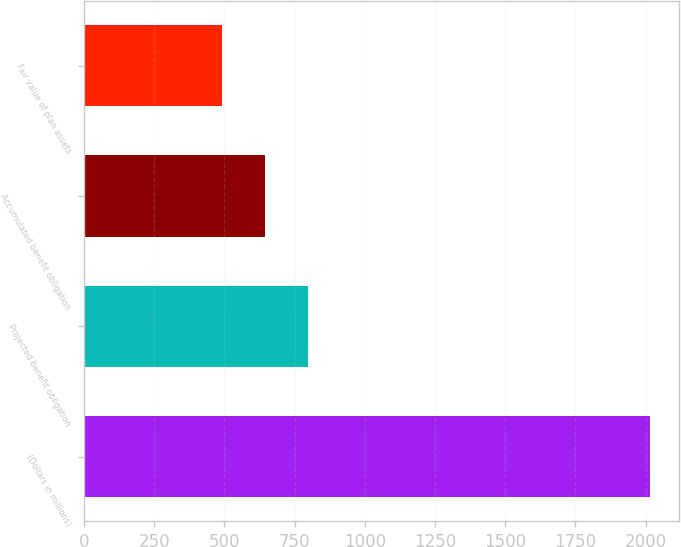Convert chart to OTSL. <chart><loc_0><loc_0><loc_500><loc_500><bar_chart><fcel>(Dollars in millions)<fcel>Projected benefit obligation<fcel>Accumulated benefit obligation<fcel>Fair value of plan assets<nl><fcel>2017<fcel>797<fcel>644.5<fcel>492<nl></chart> 